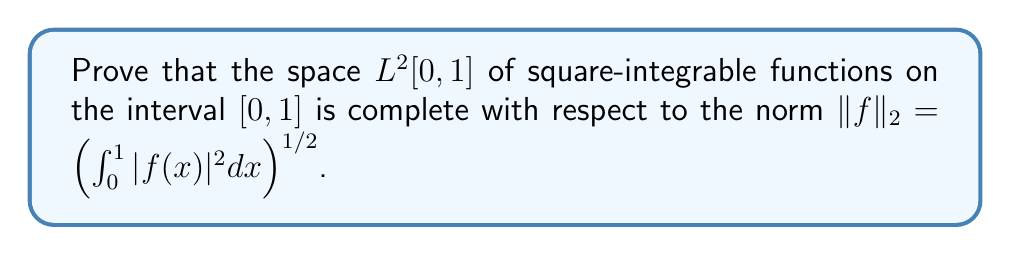Give your solution to this math problem. To prove the completeness of $L^2[0,1]$, we need to show that every Cauchy sequence in this space converges to an element within the space. Let's proceed step by step:

1) Let $(f_n)$ be a Cauchy sequence in $L^2[0,1]$. This means that for any $\epsilon > 0$, there exists an $N \in \mathbb{N}$ such that for all $m, n \geq N$:

   $$\|f_m - f_n\|_2 < \epsilon$$

2) We need to show that there exists a function $f \in L^2[0,1]$ such that $f_n \to f$ in the $L^2$ norm.

3) First, we'll prove that $(f_n)$ converges pointwise almost everywhere to some function $f$. To do this, we'll use the fact that $L^2[0,1] \subset L^1[0,1]$ and apply Riesz-Fischer theorem.

4) For any $k \in \mathbb{N}$, choose $N_k$ such that for $m, n \geq N_k$:

   $$\|f_m - f_n\|_2 < \frac{1}{2^k}$$

5) Define a subsequence $(g_k)$ by setting $g_k = f_{N_k}$. Then:

   $$\|g_{k+1} - g_k\|_2 < \frac{1}{2^k}$$

6) Consider the series:

   $$g_1 + (g_2 - g_1) + (g_3 - g_2) + \cdots$$

   The partial sums of this series are precisely the $g_k$, and we have:

   $$\sum_{k=1}^{\infty} \|g_{k+1} - g_k\|_2 < \sum_{k=1}^{\infty} \frac{1}{2^k} = 1 < \infty$$

7) By the Riesz-Fischer theorem, this series converges in $L^2[0,1]$ to some function $f$. Moreover, it converges pointwise almost everywhere to $f$.

8) Now, we need to show that the original sequence $(f_n)$ converges to $f$ in the $L^2$ norm.

9) Given $\epsilon > 0$, choose $N$ such that for $m, n \geq N$:

   $$\|f_m - f_n\|_2 < \frac{\epsilon}{2}$$

10) Choose $k$ large enough so that $N_k \geq N$ and $\|g_k - f\|_2 < \frac{\epsilon}{2}$.

11) Then for any $n \geq N$:

    $$\|f_n - f\|_2 \leq \|f_n - g_k\|_2 + \|g_k - f\|_2 < \frac{\epsilon}{2} + \frac{\epsilon}{2} = \epsilon$$

12) This proves that $f_n \to f$ in the $L^2$ norm, and thus $L^2[0,1]$ is complete.
Answer: The space $L^2[0,1]$ is complete with respect to the norm $\|f\|_2 = \left(\int_0^1 |f(x)|^2 dx\right)^{1/2}$. 